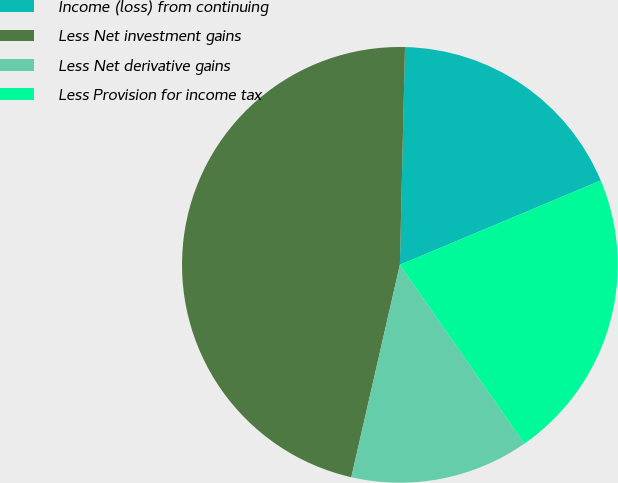Convert chart to OTSL. <chart><loc_0><loc_0><loc_500><loc_500><pie_chart><fcel>Income (loss) from continuing<fcel>Less Net investment gains<fcel>Less Net derivative gains<fcel>Less Provision for income tax<nl><fcel>18.3%<fcel>46.8%<fcel>13.26%<fcel>21.65%<nl></chart> 